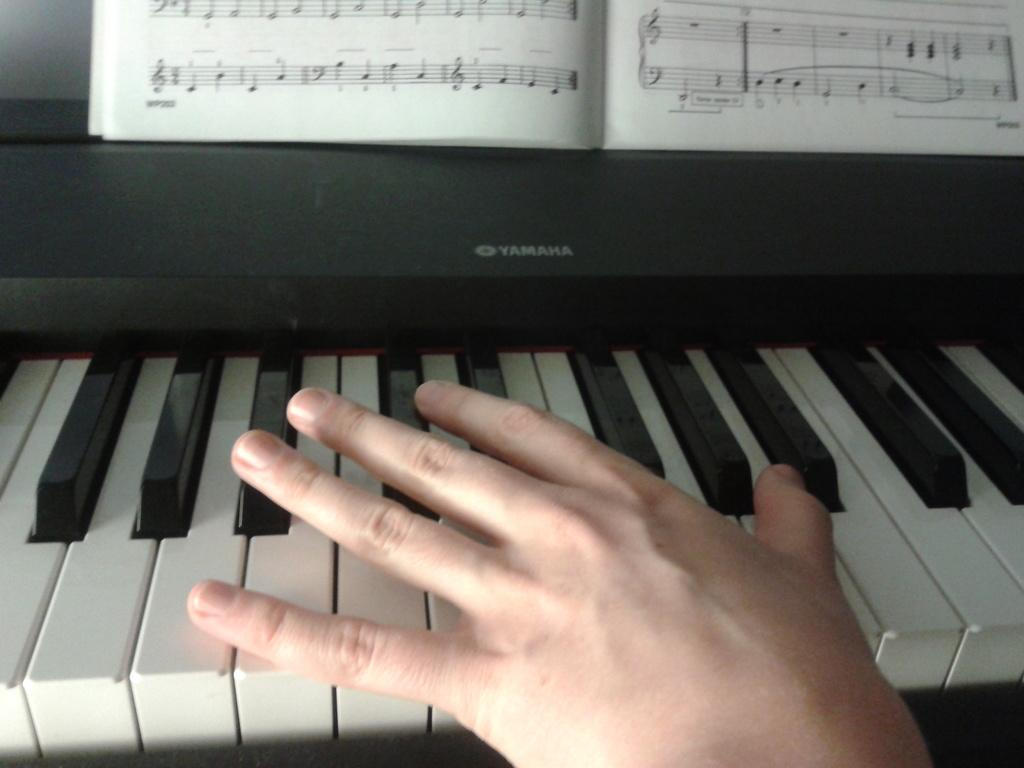What is the person's hand doing in the image? The person's hand is on a piano in the image. What else can be seen in the image besides the piano? There is a book visible in the image. How many ladybugs are sitting on the piano keys in the image? There are no ladybugs present in the image. What type of kite is being flown in the image? There is no kite present in the image. 